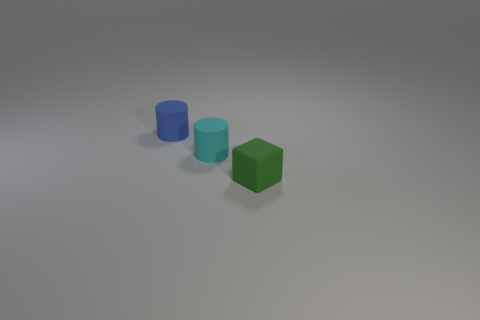Is there anything else that has the same shape as the green object?
Your answer should be compact. No. What is the material of the tiny green object?
Offer a terse response. Rubber. How many other things are the same shape as the green object?
Make the answer very short. 0. What size is the blue cylinder?
Provide a succinct answer. Small. There is a matte thing that is both right of the blue object and behind the rubber cube; what is its size?
Give a very brief answer. Small. There is a thing behind the tiny cyan matte cylinder; what is its shape?
Offer a terse response. Cylinder. Is the blue object made of the same material as the object in front of the tiny cyan thing?
Keep it short and to the point. Yes. Does the green rubber thing have the same shape as the tiny cyan object?
Ensure brevity in your answer.  No. There is another object that is the same shape as the tiny cyan thing; what material is it?
Give a very brief answer. Rubber. What color is the small matte thing that is both on the right side of the blue matte cylinder and left of the cube?
Your answer should be very brief. Cyan. 